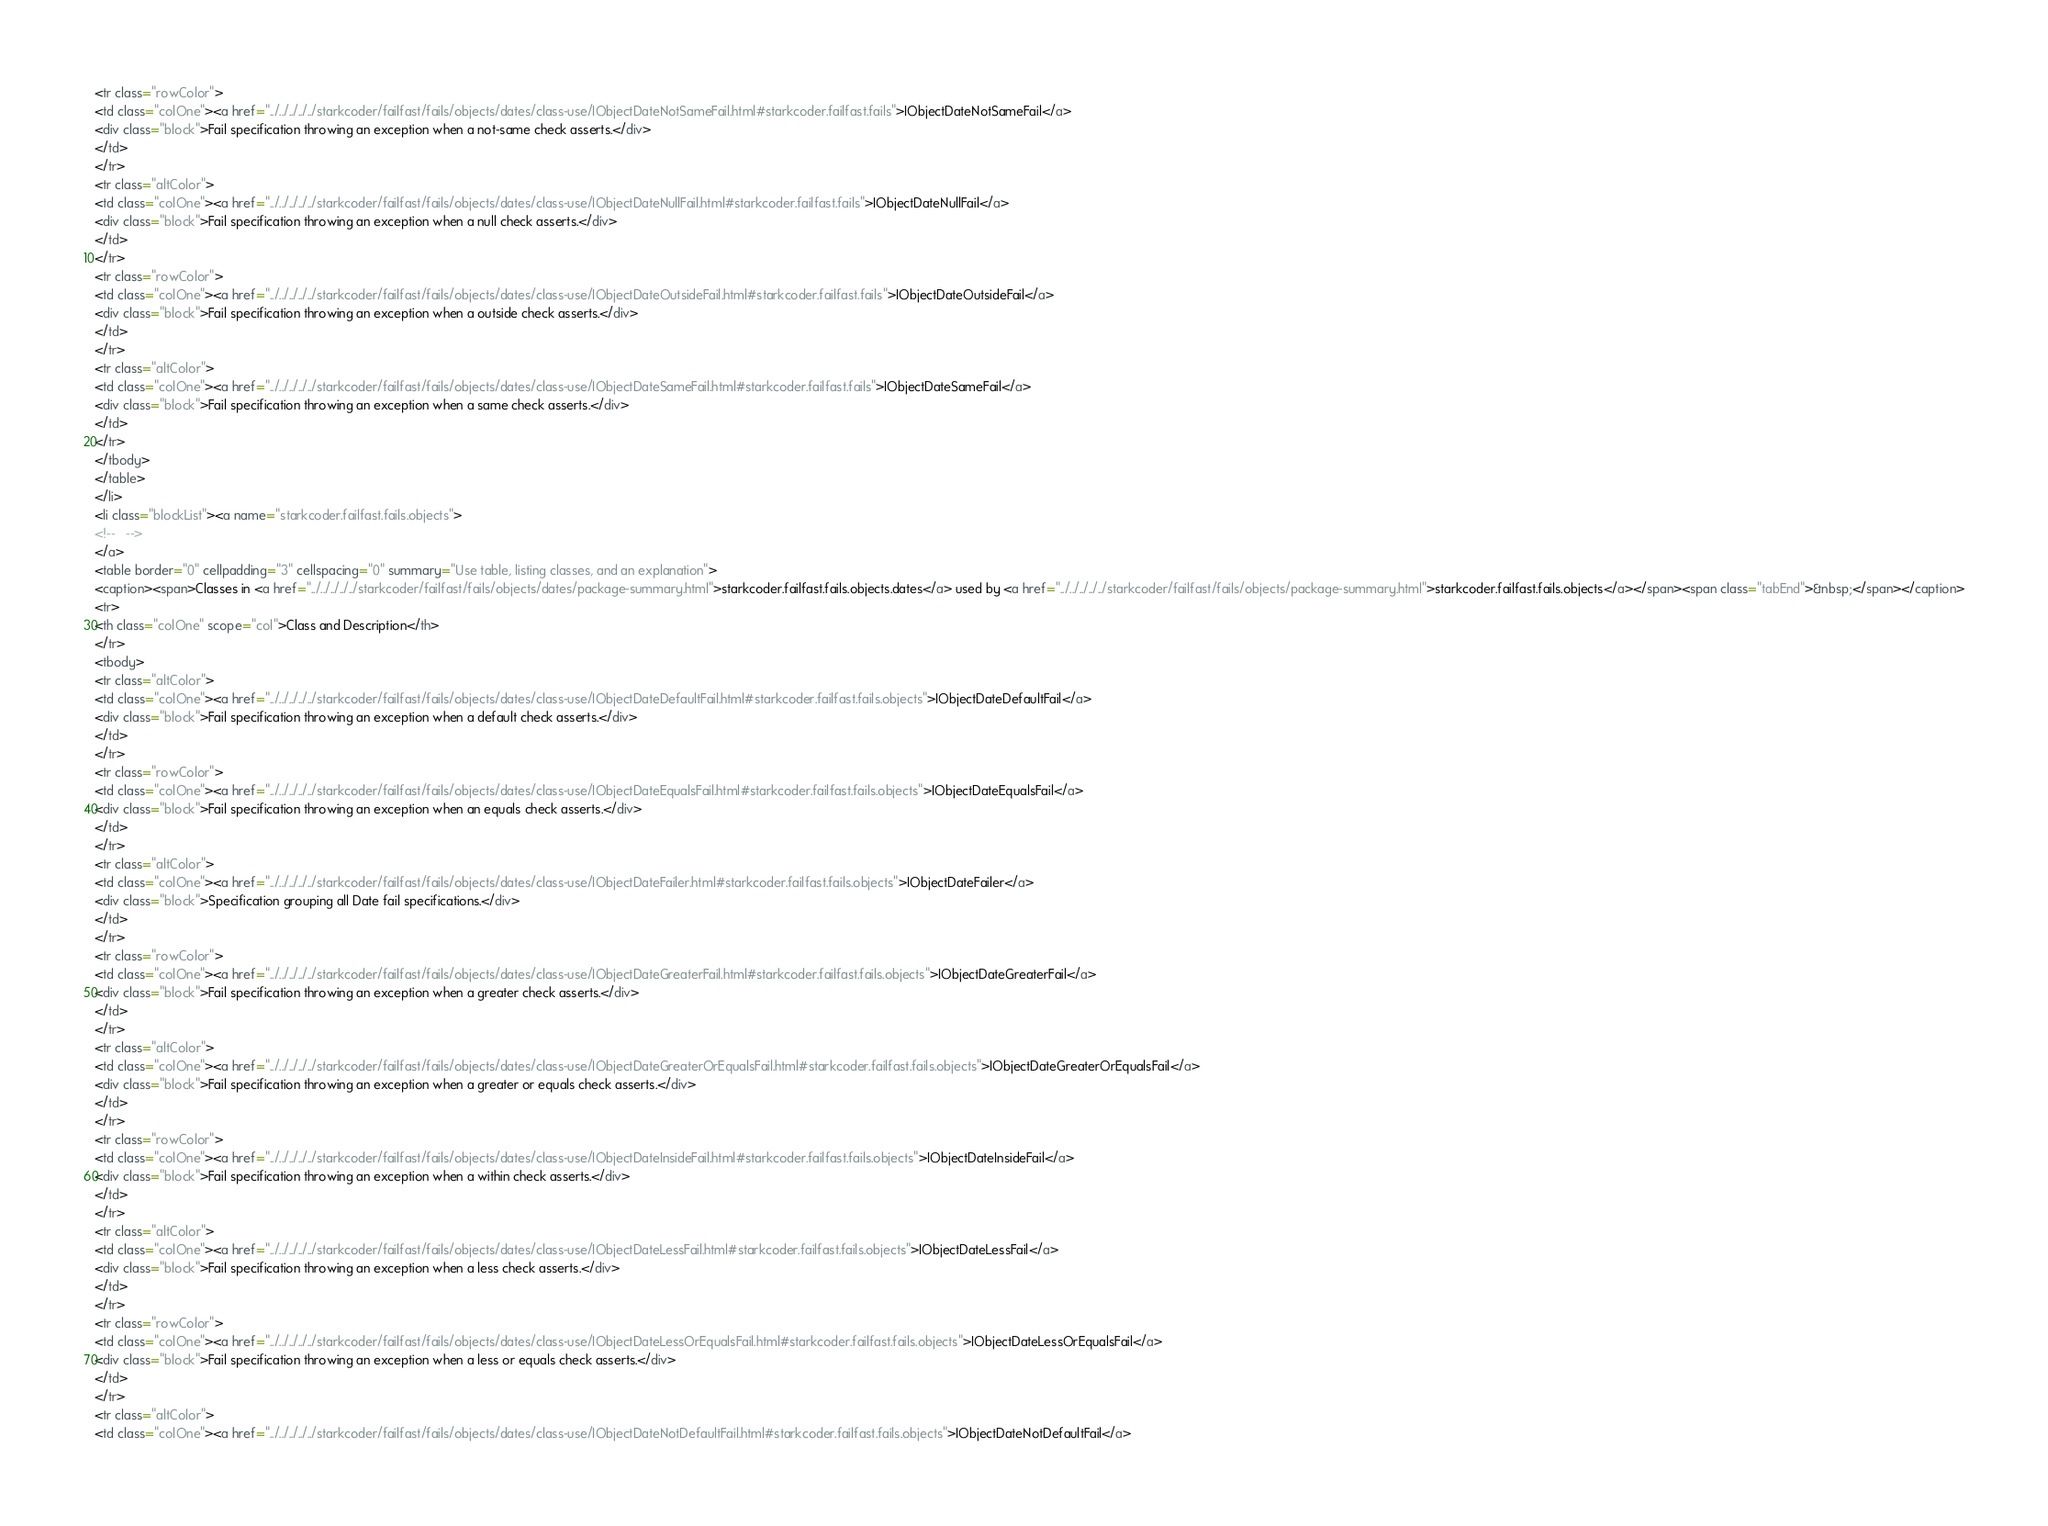Convert code to text. <code><loc_0><loc_0><loc_500><loc_500><_HTML_><tr class="rowColor">
<td class="colOne"><a href="../../../../../starkcoder/failfast/fails/objects/dates/class-use/IObjectDateNotSameFail.html#starkcoder.failfast.fails">IObjectDateNotSameFail</a>
<div class="block">Fail specification throwing an exception when a not-same check asserts.</div>
</td>
</tr>
<tr class="altColor">
<td class="colOne"><a href="../../../../../starkcoder/failfast/fails/objects/dates/class-use/IObjectDateNullFail.html#starkcoder.failfast.fails">IObjectDateNullFail</a>
<div class="block">Fail specification throwing an exception when a null check asserts.</div>
</td>
</tr>
<tr class="rowColor">
<td class="colOne"><a href="../../../../../starkcoder/failfast/fails/objects/dates/class-use/IObjectDateOutsideFail.html#starkcoder.failfast.fails">IObjectDateOutsideFail</a>
<div class="block">Fail specification throwing an exception when a outside check asserts.</div>
</td>
</tr>
<tr class="altColor">
<td class="colOne"><a href="../../../../../starkcoder/failfast/fails/objects/dates/class-use/IObjectDateSameFail.html#starkcoder.failfast.fails">IObjectDateSameFail</a>
<div class="block">Fail specification throwing an exception when a same check asserts.</div>
</td>
</tr>
</tbody>
</table>
</li>
<li class="blockList"><a name="starkcoder.failfast.fails.objects">
<!--   -->
</a>
<table border="0" cellpadding="3" cellspacing="0" summary="Use table, listing classes, and an explanation">
<caption><span>Classes in <a href="../../../../../starkcoder/failfast/fails/objects/dates/package-summary.html">starkcoder.failfast.fails.objects.dates</a> used by <a href="../../../../../starkcoder/failfast/fails/objects/package-summary.html">starkcoder.failfast.fails.objects</a></span><span class="tabEnd">&nbsp;</span></caption>
<tr>
<th class="colOne" scope="col">Class and Description</th>
</tr>
<tbody>
<tr class="altColor">
<td class="colOne"><a href="../../../../../starkcoder/failfast/fails/objects/dates/class-use/IObjectDateDefaultFail.html#starkcoder.failfast.fails.objects">IObjectDateDefaultFail</a>
<div class="block">Fail specification throwing an exception when a default check asserts.</div>
</td>
</tr>
<tr class="rowColor">
<td class="colOne"><a href="../../../../../starkcoder/failfast/fails/objects/dates/class-use/IObjectDateEqualsFail.html#starkcoder.failfast.fails.objects">IObjectDateEqualsFail</a>
<div class="block">Fail specification throwing an exception when an equals check asserts.</div>
</td>
</tr>
<tr class="altColor">
<td class="colOne"><a href="../../../../../starkcoder/failfast/fails/objects/dates/class-use/IObjectDateFailer.html#starkcoder.failfast.fails.objects">IObjectDateFailer</a>
<div class="block">Specification grouping all Date fail specifications.</div>
</td>
</tr>
<tr class="rowColor">
<td class="colOne"><a href="../../../../../starkcoder/failfast/fails/objects/dates/class-use/IObjectDateGreaterFail.html#starkcoder.failfast.fails.objects">IObjectDateGreaterFail</a>
<div class="block">Fail specification throwing an exception when a greater check asserts.</div>
</td>
</tr>
<tr class="altColor">
<td class="colOne"><a href="../../../../../starkcoder/failfast/fails/objects/dates/class-use/IObjectDateGreaterOrEqualsFail.html#starkcoder.failfast.fails.objects">IObjectDateGreaterOrEqualsFail</a>
<div class="block">Fail specification throwing an exception when a greater or equals check asserts.</div>
</td>
</tr>
<tr class="rowColor">
<td class="colOne"><a href="../../../../../starkcoder/failfast/fails/objects/dates/class-use/IObjectDateInsideFail.html#starkcoder.failfast.fails.objects">IObjectDateInsideFail</a>
<div class="block">Fail specification throwing an exception when a within check asserts.</div>
</td>
</tr>
<tr class="altColor">
<td class="colOne"><a href="../../../../../starkcoder/failfast/fails/objects/dates/class-use/IObjectDateLessFail.html#starkcoder.failfast.fails.objects">IObjectDateLessFail</a>
<div class="block">Fail specification throwing an exception when a less check asserts.</div>
</td>
</tr>
<tr class="rowColor">
<td class="colOne"><a href="../../../../../starkcoder/failfast/fails/objects/dates/class-use/IObjectDateLessOrEqualsFail.html#starkcoder.failfast.fails.objects">IObjectDateLessOrEqualsFail</a>
<div class="block">Fail specification throwing an exception when a less or equals check asserts.</div>
</td>
</tr>
<tr class="altColor">
<td class="colOne"><a href="../../../../../starkcoder/failfast/fails/objects/dates/class-use/IObjectDateNotDefaultFail.html#starkcoder.failfast.fails.objects">IObjectDateNotDefaultFail</a></code> 